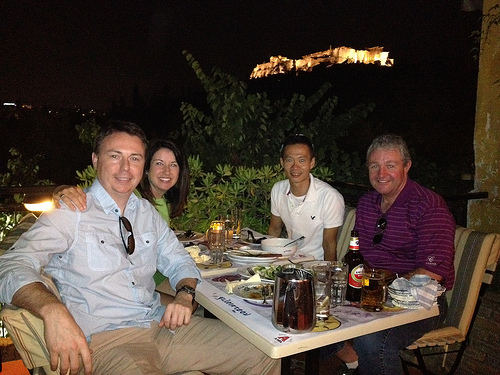What time of day does this scene seem to be taking place? The sky is dark and the historical structure in the background is illuminated, suggesting it's nighttime. 